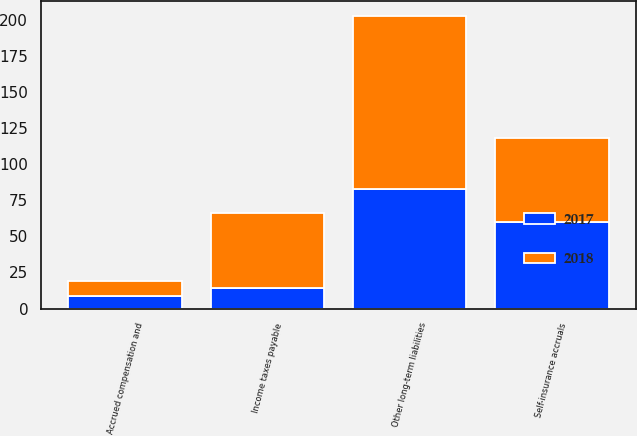<chart> <loc_0><loc_0><loc_500><loc_500><stacked_bar_chart><ecel><fcel>Self-insurance accruals<fcel>Income taxes payable<fcel>Accrued compensation and<fcel>Other long-term liabilities<nl><fcel>2017<fcel>60<fcel>14<fcel>9<fcel>83<nl><fcel>2018<fcel>58<fcel>52<fcel>10<fcel>120<nl></chart> 